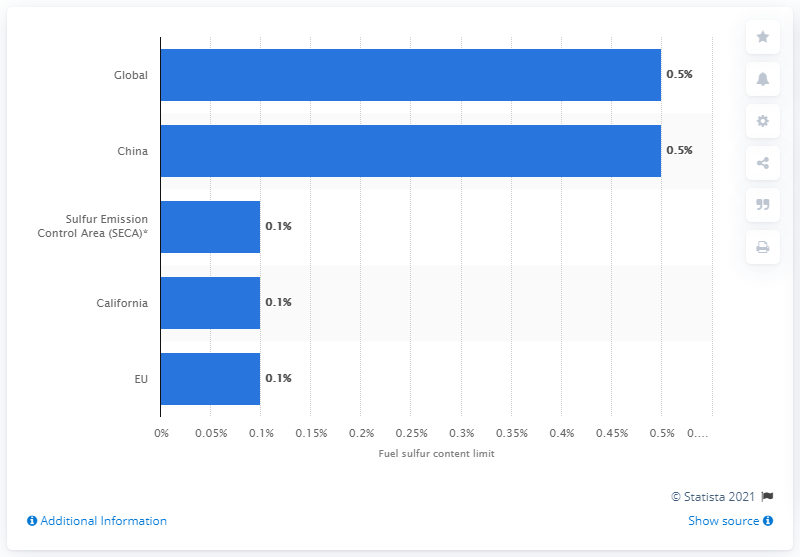Indicate a few pertinent items in this graphic. The sulfur content of fuel types that ships can use is between 0.5 and 1%. 